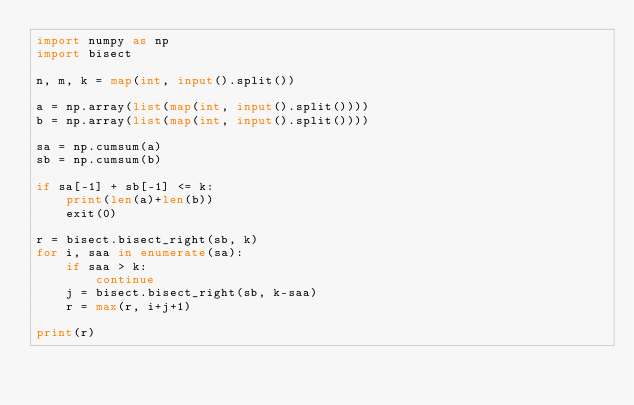Convert code to text. <code><loc_0><loc_0><loc_500><loc_500><_Python_>import numpy as np
import bisect

n, m, k = map(int, input().split())

a = np.array(list(map(int, input().split())))
b = np.array(list(map(int, input().split())))

sa = np.cumsum(a)
sb = np.cumsum(b)

if sa[-1] + sb[-1] <= k:
    print(len(a)+len(b))
    exit(0)

r = bisect.bisect_right(sb, k)
for i, saa in enumerate(sa):
    if saa > k:
        continue
    j = bisect.bisect_right(sb, k-saa)
    r = max(r, i+j+1)

print(r)
</code> 